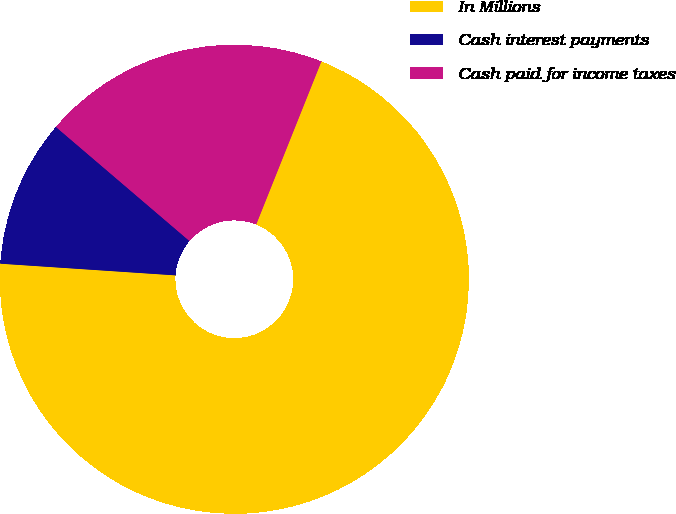Convert chart. <chart><loc_0><loc_0><loc_500><loc_500><pie_chart><fcel>In Millions<fcel>Cash interest payments<fcel>Cash paid for income taxes<nl><fcel>70.01%<fcel>10.19%<fcel>19.8%<nl></chart> 